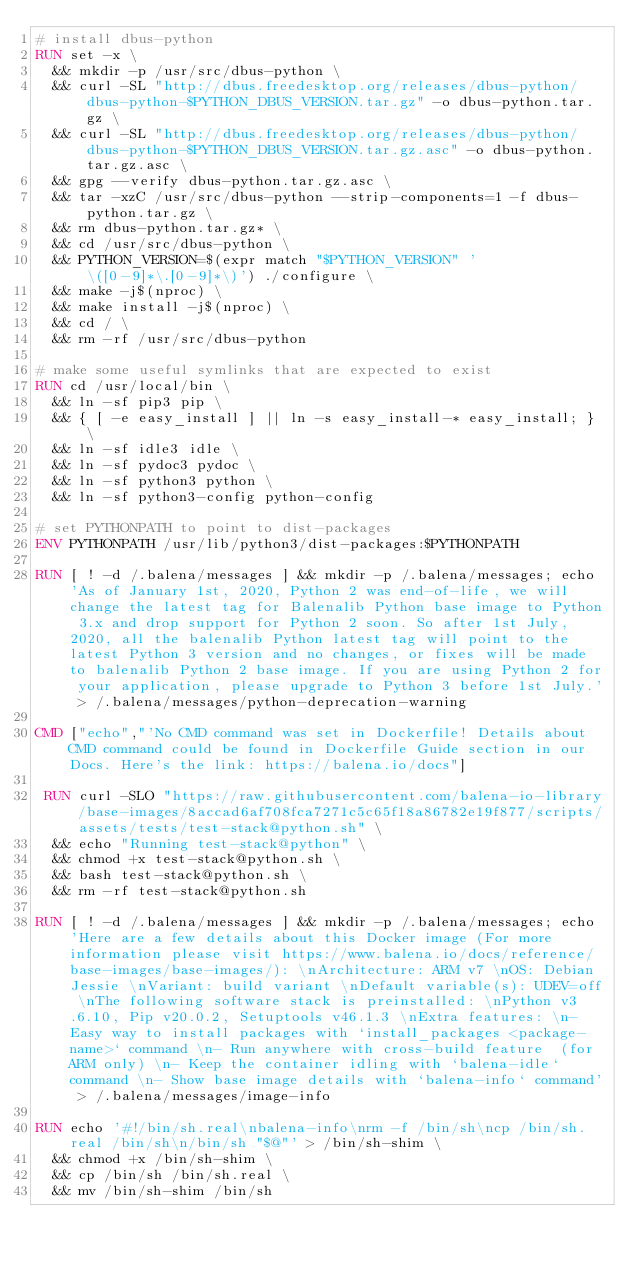Convert code to text. <code><loc_0><loc_0><loc_500><loc_500><_Dockerfile_># install dbus-python
RUN set -x \
	&& mkdir -p /usr/src/dbus-python \
	&& curl -SL "http://dbus.freedesktop.org/releases/dbus-python/dbus-python-$PYTHON_DBUS_VERSION.tar.gz" -o dbus-python.tar.gz \
	&& curl -SL "http://dbus.freedesktop.org/releases/dbus-python/dbus-python-$PYTHON_DBUS_VERSION.tar.gz.asc" -o dbus-python.tar.gz.asc \
	&& gpg --verify dbus-python.tar.gz.asc \
	&& tar -xzC /usr/src/dbus-python --strip-components=1 -f dbus-python.tar.gz \
	&& rm dbus-python.tar.gz* \
	&& cd /usr/src/dbus-python \
	&& PYTHON_VERSION=$(expr match "$PYTHON_VERSION" '\([0-9]*\.[0-9]*\)') ./configure \
	&& make -j$(nproc) \
	&& make install -j$(nproc) \
	&& cd / \
	&& rm -rf /usr/src/dbus-python

# make some useful symlinks that are expected to exist
RUN cd /usr/local/bin \
	&& ln -sf pip3 pip \
	&& { [ -e easy_install ] || ln -s easy_install-* easy_install; } \
	&& ln -sf idle3 idle \
	&& ln -sf pydoc3 pydoc \
	&& ln -sf python3 python \
	&& ln -sf python3-config python-config

# set PYTHONPATH to point to dist-packages
ENV PYTHONPATH /usr/lib/python3/dist-packages:$PYTHONPATH

RUN [ ! -d /.balena/messages ] && mkdir -p /.balena/messages; echo 'As of January 1st, 2020, Python 2 was end-of-life, we will change the latest tag for Balenalib Python base image to Python 3.x and drop support for Python 2 soon. So after 1st July, 2020, all the balenalib Python latest tag will point to the latest Python 3 version and no changes, or fixes will be made to balenalib Python 2 base image. If you are using Python 2 for your application, please upgrade to Python 3 before 1st July.' > /.balena/messages/python-deprecation-warning

CMD ["echo","'No CMD command was set in Dockerfile! Details about CMD command could be found in Dockerfile Guide section in our Docs. Here's the link: https://balena.io/docs"]

 RUN curl -SLO "https://raw.githubusercontent.com/balena-io-library/base-images/8accad6af708fca7271c5c65f18a86782e19f877/scripts/assets/tests/test-stack@python.sh" \
  && echo "Running test-stack@python" \
  && chmod +x test-stack@python.sh \
  && bash test-stack@python.sh \
  && rm -rf test-stack@python.sh 

RUN [ ! -d /.balena/messages ] && mkdir -p /.balena/messages; echo 'Here are a few details about this Docker image (For more information please visit https://www.balena.io/docs/reference/base-images/base-images/): \nArchitecture: ARM v7 \nOS: Debian Jessie \nVariant: build variant \nDefault variable(s): UDEV=off \nThe following software stack is preinstalled: \nPython v3.6.10, Pip v20.0.2, Setuptools v46.1.3 \nExtra features: \n- Easy way to install packages with `install_packages <package-name>` command \n- Run anywhere with cross-build feature  (for ARM only) \n- Keep the container idling with `balena-idle` command \n- Show base image details with `balena-info` command' > /.balena/messages/image-info

RUN echo '#!/bin/sh.real\nbalena-info\nrm -f /bin/sh\ncp /bin/sh.real /bin/sh\n/bin/sh "$@"' > /bin/sh-shim \
	&& chmod +x /bin/sh-shim \
	&& cp /bin/sh /bin/sh.real \
	&& mv /bin/sh-shim /bin/sh</code> 